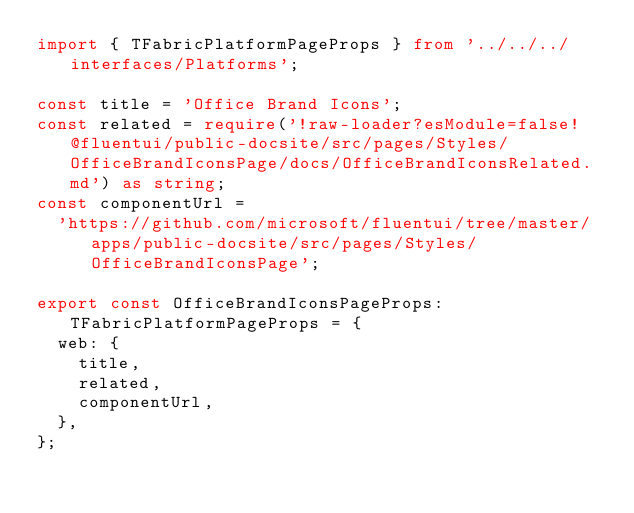<code> <loc_0><loc_0><loc_500><loc_500><_TypeScript_>import { TFabricPlatformPageProps } from '../../../interfaces/Platforms';

const title = 'Office Brand Icons';
const related = require('!raw-loader?esModule=false!@fluentui/public-docsite/src/pages/Styles/OfficeBrandIconsPage/docs/OfficeBrandIconsRelated.md') as string;
const componentUrl =
  'https://github.com/microsoft/fluentui/tree/master/apps/public-docsite/src/pages/Styles/OfficeBrandIconsPage';

export const OfficeBrandIconsPageProps: TFabricPlatformPageProps = {
  web: {
    title,
    related,
    componentUrl,
  },
};
</code> 